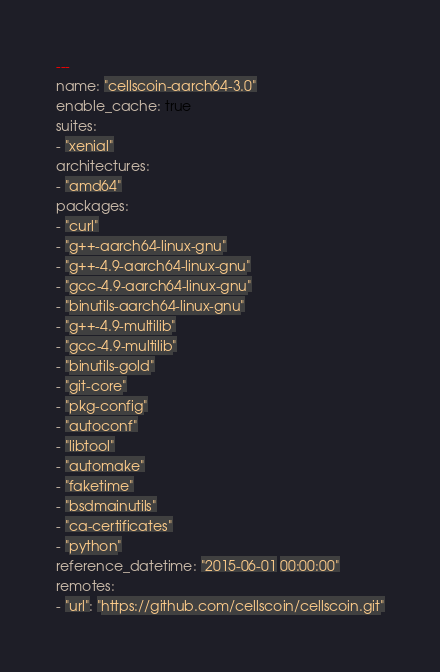<code> <loc_0><loc_0><loc_500><loc_500><_YAML_>---
name: "cellscoin-aarch64-3.0"
enable_cache: true
suites:
- "xenial"
architectures:
- "amd64"
packages:
- "curl"
- "g++-aarch64-linux-gnu"
- "g++-4.9-aarch64-linux-gnu"
- "gcc-4.9-aarch64-linux-gnu"
- "binutils-aarch64-linux-gnu"
- "g++-4.9-multilib"
- "gcc-4.9-multilib"
- "binutils-gold"
- "git-core"
- "pkg-config"
- "autoconf"
- "libtool"
- "automake"
- "faketime"
- "bsdmainutils"
- "ca-certificates"
- "python"
reference_datetime: "2015-06-01 00:00:00"
remotes:
- "url": "https://github.com/cellscoin/cellscoin.git"</code> 